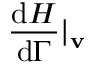<formula> <loc_0><loc_0><loc_500><loc_500>\frac { d H } { d \Gamma } | _ { v }</formula> 